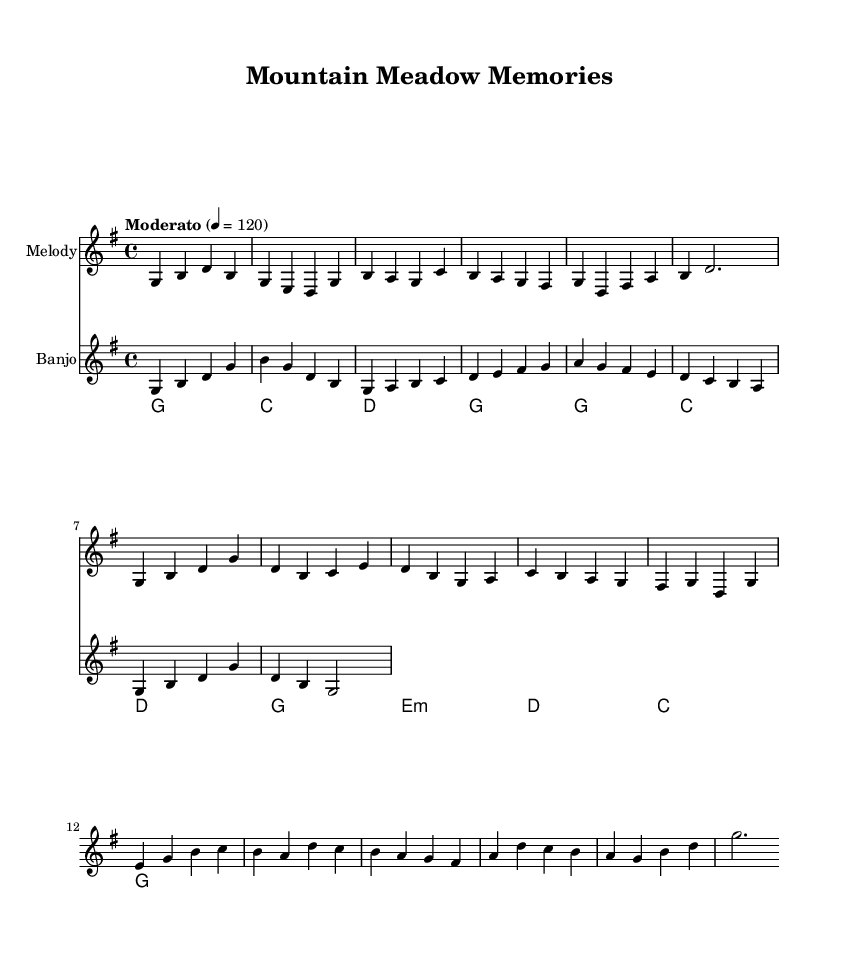What is the key signature of this music? The key signature is G major, which has one sharp (F#). This can be identified by looking at the beginning of the staff where the sharp is indicated.
Answer: G major What is the time signature of the music? The time signature is 4/4, as shown at the beginning of the piece. This means there are four beats per measure and the quarter note equals one beat.
Answer: 4/4 What is the indicated tempo for this piece? The tempo is marked "Moderato" at 120 beats per minute. This phrase is placed above the staff, indicating that the composition should be played at a moderate speed.
Answer: Moderato 120 What is the style of the instrumental solo in this piece? The instrumental solo is played on the banjo, which reflects a traditional bluegrass style typical in country music. This is noted by the designated staff labeled "Banjo" and the style of the notes which suggest fast picking techniques.
Answer: Banjo How many measures are there in the verse section? The verse consists of six measures, which can be counted directly by looking at the music and counting the bar lines in the verse section.
Answer: Six What chord follows the E minor chord in the chord progression? The chord that follows the E minor (E:m) is D major, as noted in the chord names below the staff. This provides a clear progression of harmony used in the song.
Answer: D major What is the last note of the bridge section? The last note of the bridge section is G, which can be identified at the end of the bridge melody line where the notes conclude the phrase.
Answer: G 